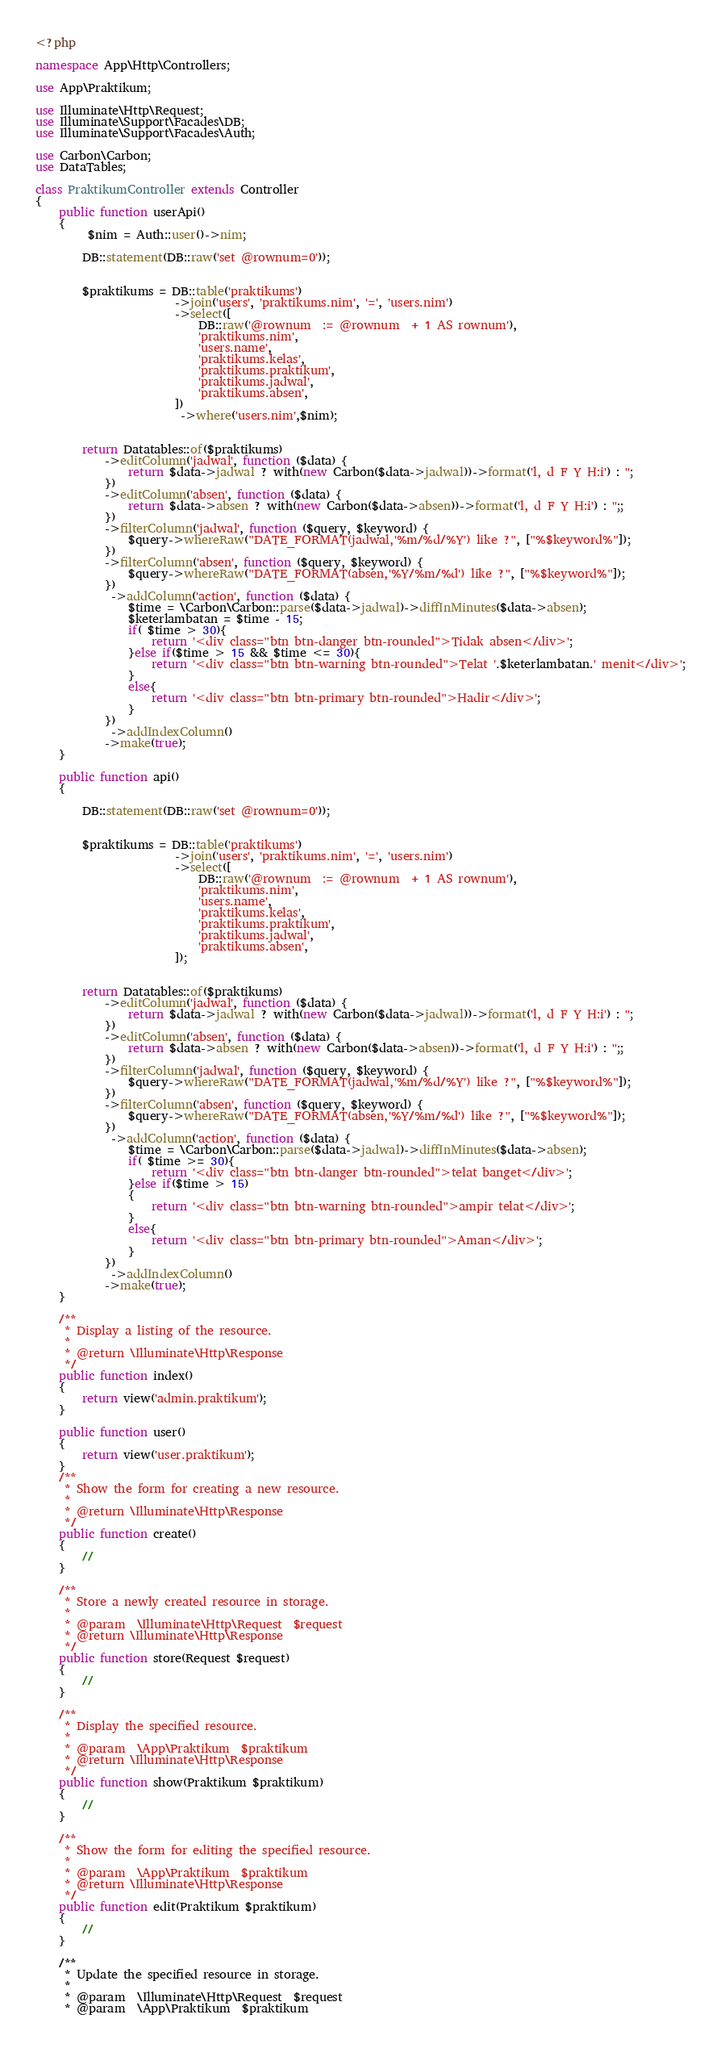<code> <loc_0><loc_0><loc_500><loc_500><_PHP_><?php

namespace App\Http\Controllers;

use App\Praktikum;

use Illuminate\Http\Request;
use Illuminate\Support\Facades\DB;
use Illuminate\Support\Facades\Auth;

use Carbon\Carbon; 
use DataTables;

class PraktikumController extends Controller
{
    public function userApi()
    {
         $nim = Auth::user()->nim;

        DB::statement(DB::raw('set @rownum=0'));
        
        
        $praktikums = DB::table('praktikums')
                        ->join('users', 'praktikums.nim', '=', 'users.nim')
                        ->select([
                            DB::raw('@rownum  := @rownum  + 1 AS rownum'),
                            'praktikums.nim',
                            'users.name',
                            'praktikums.kelas',
                            'praktikums.praktikum',
                            'praktikums.jadwal',
                            'praktikums.absen',
                        ])
                         ->where('users.nim',$nim);


        return Datatables::of($praktikums)
            ->editColumn('jadwal', function ($data) {
                return $data->jadwal ? with(new Carbon($data->jadwal))->format('l, d F Y H:i') : '';
            })
            ->editColumn('absen', function ($data) {
                return $data->absen ? with(new Carbon($data->absen))->format('l, d F Y H:i') : '';;
            })
            ->filterColumn('jadwal', function ($query, $keyword) {
                $query->whereRaw("DATE_FORMAT(jadwal,'%m/%d/%Y') like ?", ["%$keyword%"]);
            })
            ->filterColumn('absen', function ($query, $keyword) {
                $query->whereRaw("DATE_FORMAT(absen,'%Y/%m/%d') like ?", ["%$keyword%"]);
            })
             ->addColumn('action', function ($data) {
                $time = \Carbon\Carbon::parse($data->jadwal)->diffInMinutes($data->absen);
                $keterlambatan = $time - 15;
                if( $time > 30){
                    return '<div class="btn btn-danger btn-rounded">Tidak absen</div>';
                }else if($time > 15 && $time <= 30){
                    return '<div class="btn btn-warning btn-rounded">Telat '.$keterlambatan.' menit</div>';
                }
                else{
                    return '<div class="btn btn-primary btn-rounded">Hadir</div>';
                }
            })
             ->addIndexColumn()
            ->make(true);
    }

    public function api() 
    {
        
        DB::statement(DB::raw('set @rownum=0'));
        
        
        $praktikums = DB::table('praktikums')
                        ->join('users', 'praktikums.nim', '=', 'users.nim')
                        ->select([
                            DB::raw('@rownum  := @rownum  + 1 AS rownum'),
                            'praktikums.nim',
                            'users.name',
                            'praktikums.kelas',
                            'praktikums.praktikum',
                            'praktikums.jadwal',
                            'praktikums.absen',
                        ]);


        return Datatables::of($praktikums)
            ->editColumn('jadwal', function ($data) {
                return $data->jadwal ? with(new Carbon($data->jadwal))->format('l, d F Y H:i') : '';
            })
            ->editColumn('absen', function ($data) {
                return $data->absen ? with(new Carbon($data->absen))->format('l, d F Y H:i') : '';;
            })
            ->filterColumn('jadwal', function ($query, $keyword) {
                $query->whereRaw("DATE_FORMAT(jadwal,'%m/%d/%Y') like ?", ["%$keyword%"]);
            })
            ->filterColumn('absen', function ($query, $keyword) {
                $query->whereRaw("DATE_FORMAT(absen,'%Y/%m/%d') like ?", ["%$keyword%"]);
            })
             ->addColumn('action', function ($data) {
                $time = \Carbon\Carbon::parse($data->jadwal)->diffInMinutes($data->absen);
                if( $time >= 30){
                    return '<div class="btn btn-danger btn-rounded">telat banget</div>';
                }else if($time > 15)
                {
                    return '<div class="btn btn-warning btn-rounded">ampir telat</div>';
                }
                else{
                    return '<div class="btn btn-primary btn-rounded">Aman</div>';
                }
            })
             ->addIndexColumn()
            ->make(true);
    }

    /**
     * Display a listing of the resource.
     *
     * @return \Illuminate\Http\Response
     */
    public function index()
    {
        return view('admin.praktikum');
    }

    public function user()
    {
        return view('user.praktikum');
    }
    /**
     * Show the form for creating a new resource.
     *
     * @return \Illuminate\Http\Response
     */
    public function create()
    {
        //
    }

    /**
     * Store a newly created resource in storage.
     *
     * @param  \Illuminate\Http\Request  $request
     * @return \Illuminate\Http\Response
     */
    public function store(Request $request)
    {
        //
    }

    /**
     * Display the specified resource.
     *
     * @param  \App\Praktikum  $praktikum
     * @return \Illuminate\Http\Response
     */
    public function show(Praktikum $praktikum)
    {
        //
    }

    /**
     * Show the form for editing the specified resource.
     *
     * @param  \App\Praktikum  $praktikum
     * @return \Illuminate\Http\Response
     */
    public function edit(Praktikum $praktikum)
    {
        //
    }

    /**
     * Update the specified resource in storage.
     *
     * @param  \Illuminate\Http\Request  $request
     * @param  \App\Praktikum  $praktikum</code> 